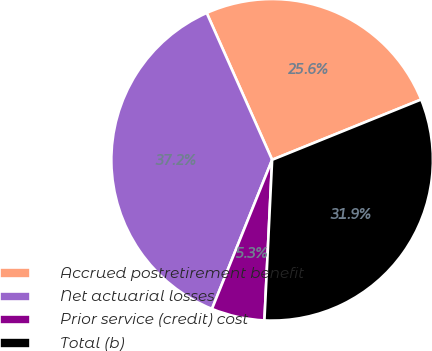Convert chart to OTSL. <chart><loc_0><loc_0><loc_500><loc_500><pie_chart><fcel>Accrued postretirement benefit<fcel>Net actuarial losses<fcel>Prior service (credit) cost<fcel>Total (b)<nl><fcel>25.55%<fcel>37.22%<fcel>5.34%<fcel>31.88%<nl></chart> 